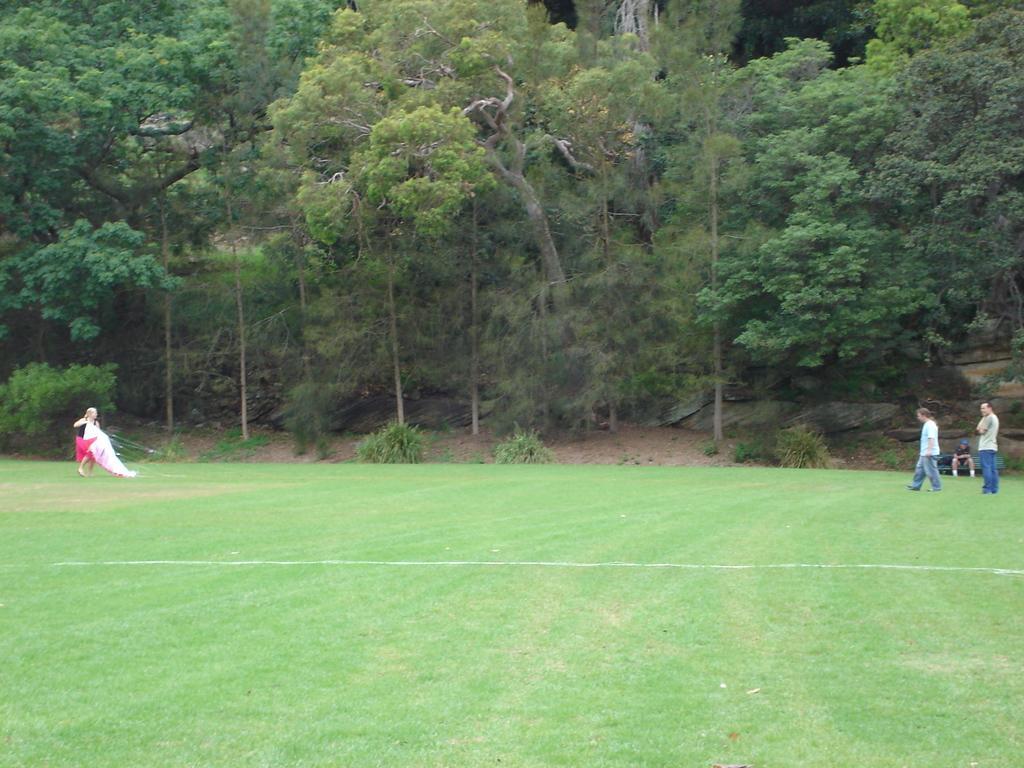Could you give a brief overview of what you see in this image? In this image there is a person standing and holding a kite, two persons standing on the grass, a person sitting , and in the background there are trees. 